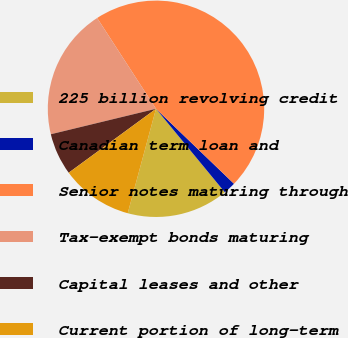Convert chart to OTSL. <chart><loc_0><loc_0><loc_500><loc_500><pie_chart><fcel>225 billion revolving credit<fcel>Canadian term loan and<fcel>Senior notes maturing through<fcel>Tax-exempt bonds maturing<fcel>Capital leases and other<fcel>Current portion of long-term<nl><fcel>15.18%<fcel>1.84%<fcel>46.33%<fcel>19.63%<fcel>6.28%<fcel>10.73%<nl></chart> 